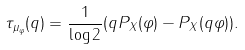Convert formula to latex. <formula><loc_0><loc_0><loc_500><loc_500>\tau _ { \mu _ { \varphi } } ( q ) = \frac { 1 } { \log 2 } ( q P _ { X } ( \varphi ) - P _ { X } ( q \varphi ) ) .</formula> 